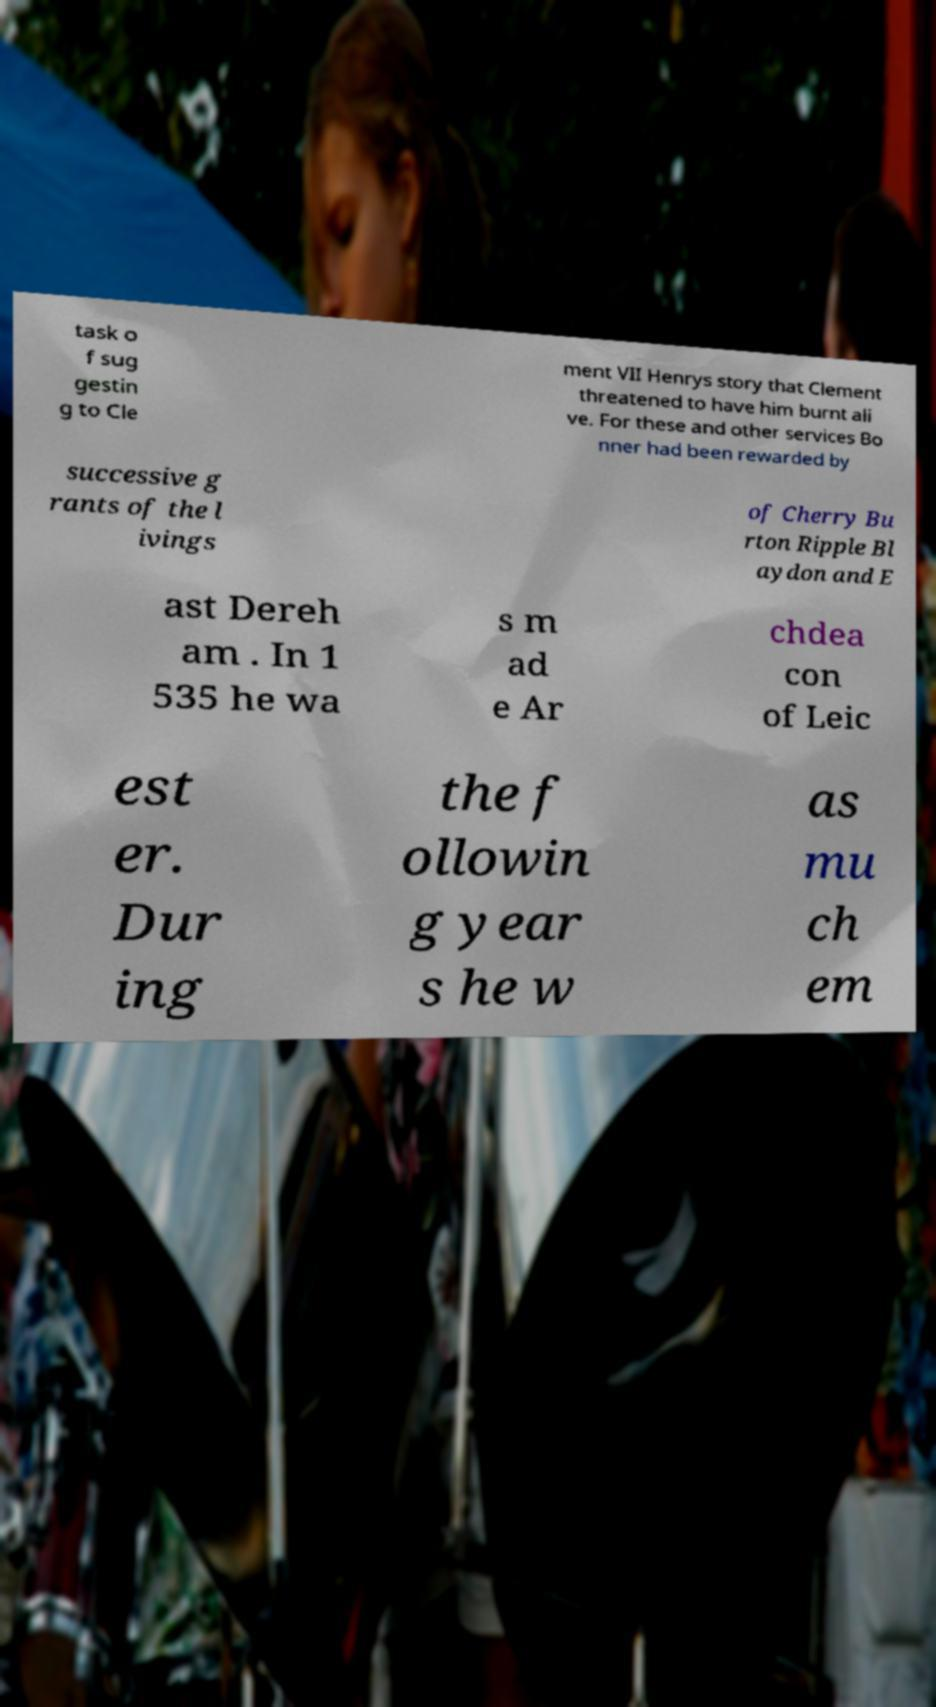Could you assist in decoding the text presented in this image and type it out clearly? task o f sug gestin g to Cle ment VII Henrys story that Clement threatened to have him burnt ali ve. For these and other services Bo nner had been rewarded by successive g rants of the l ivings of Cherry Bu rton Ripple Bl aydon and E ast Dereh am . In 1 535 he wa s m ad e Ar chdea con of Leic est er. Dur ing the f ollowin g year s he w as mu ch em 